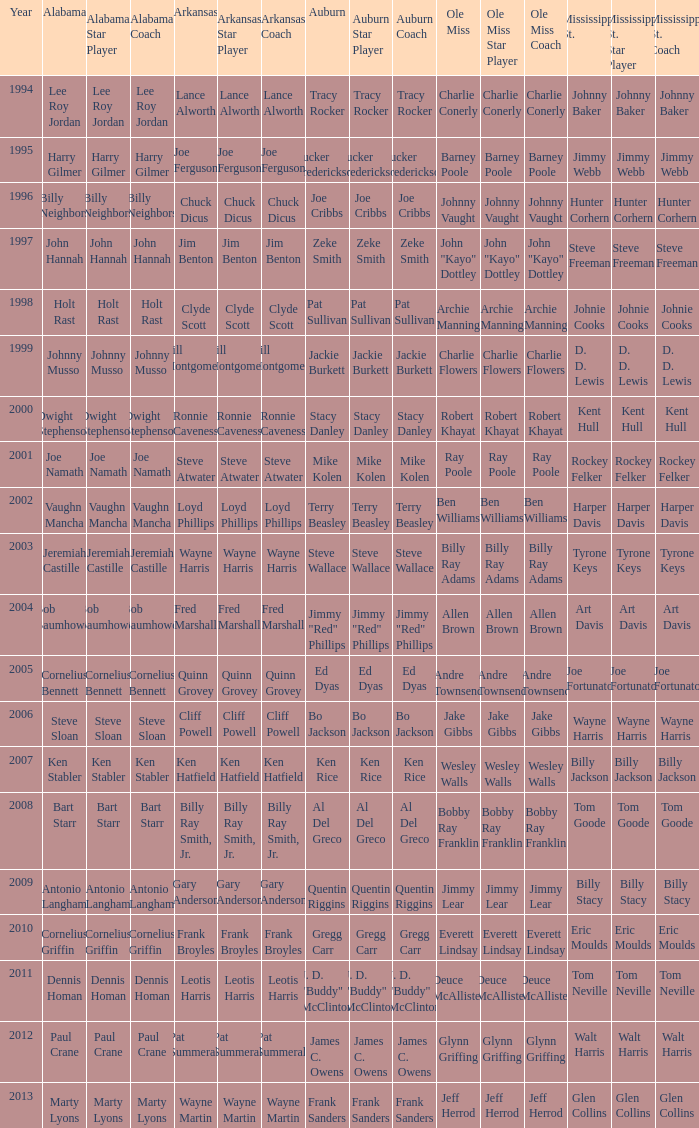Who is the Arkansas player associated with Ken Stabler? Ken Hatfield. 